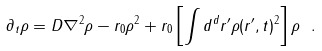Convert formula to latex. <formula><loc_0><loc_0><loc_500><loc_500>\partial _ { t } \rho = D \nabla ^ { 2 } \rho - r _ { 0 } \rho ^ { 2 } + r _ { 0 } \left [ \int d ^ { d } r ^ { \prime } \rho ( { r } ^ { \prime } , t ) ^ { 2 } \right ] \rho \ .</formula> 